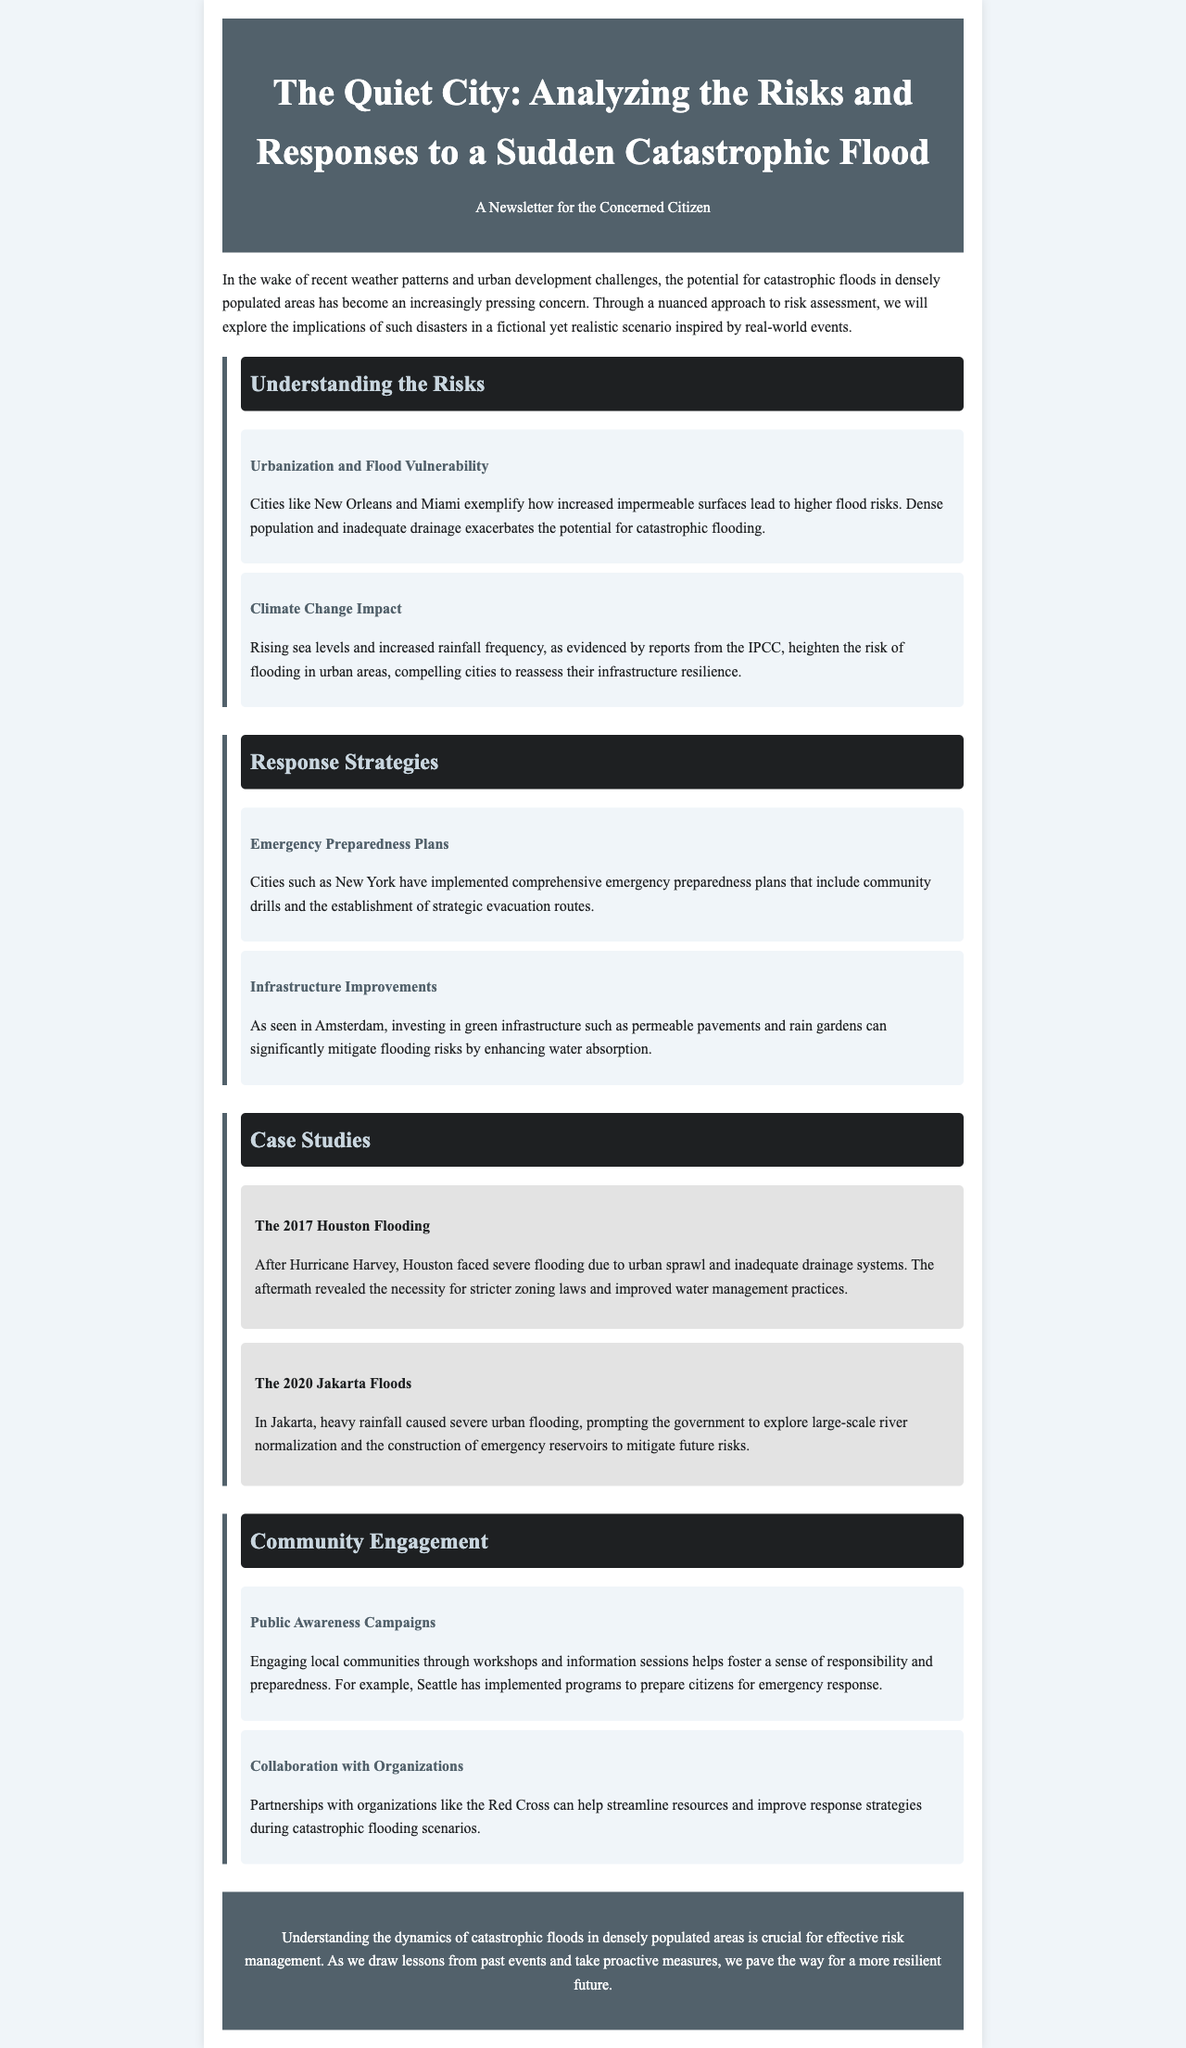What is the title of the newsletter? The title is prominently displayed in the header of the document, stating the primary focus of the newsletter.
Answer: The Quiet City: Analyzing the Risks and Responses to a Sudden Catastrophic Flood Which case study discusses Hurricane Harvey? The newsletter includes case studies, each with a specific event highlighted. The relevant case study is about severe flooding following an impactful hurricane.
Answer: The 2017 Houston Flooding What city is mentioned as an example of emergency preparedness plans? The document lists a city known for its effective emergency preparedness plans as part of the response strategies.
Answer: New York What is one impact of climate change mentioned? The document discusses climate change effects, highlighting a specific consequence related to urban flooding risks.
Answer: Rising sea levels What type of community engagement is discussed in the newsletter? The document elaborates on strategies to involve citizens in flood preparedness efforts, particularly through information sharing.
Answer: Public Awareness Campaigns Which city utilized green infrastructure as a flood mitigation strategy? The newsletter provides an example of a city that has invested in environmentally friendly infrastructure to manage flood risks.
Answer: Amsterdam 